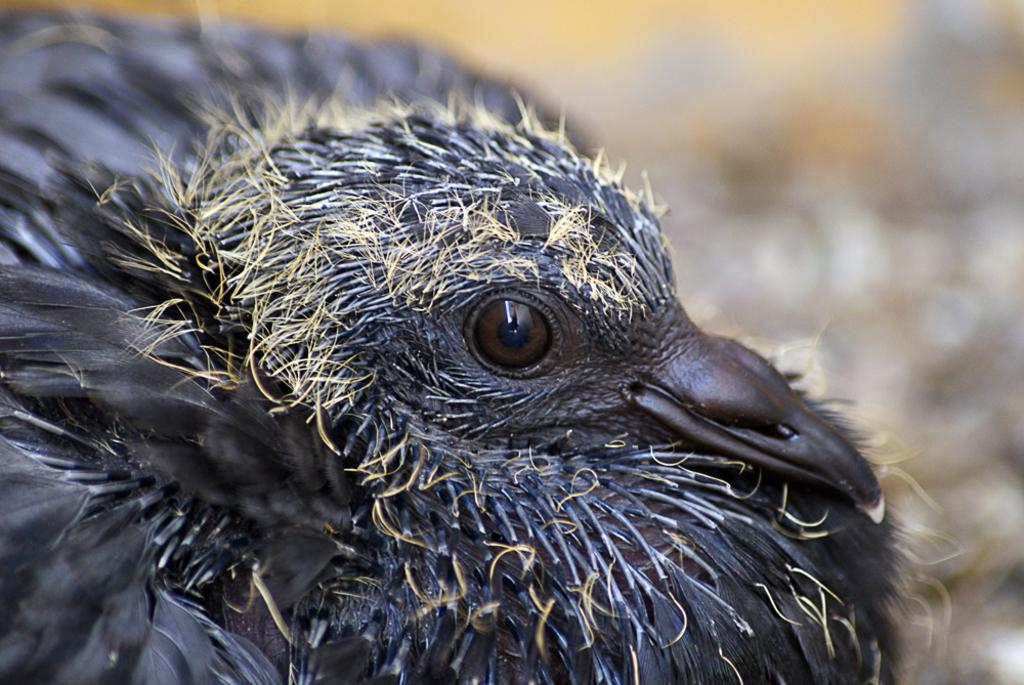What type of bird can be seen in the image? There is a black color bird in the image. Can you describe the quality of the background in the image? The image is blurry in the background. What type of tax is being discussed in the image? There is no discussion of tax in the image; it features a black color bird and a blurry background. How many beds are visible in the image? There are no beds present in the image. 